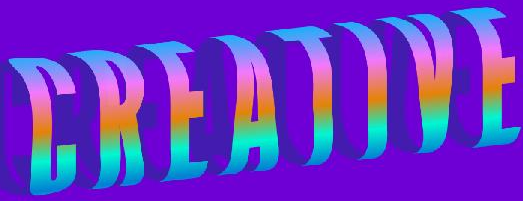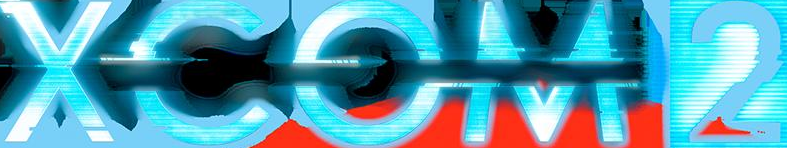Identify the words shown in these images in order, separated by a semicolon. CREATIVE; XCOM2 